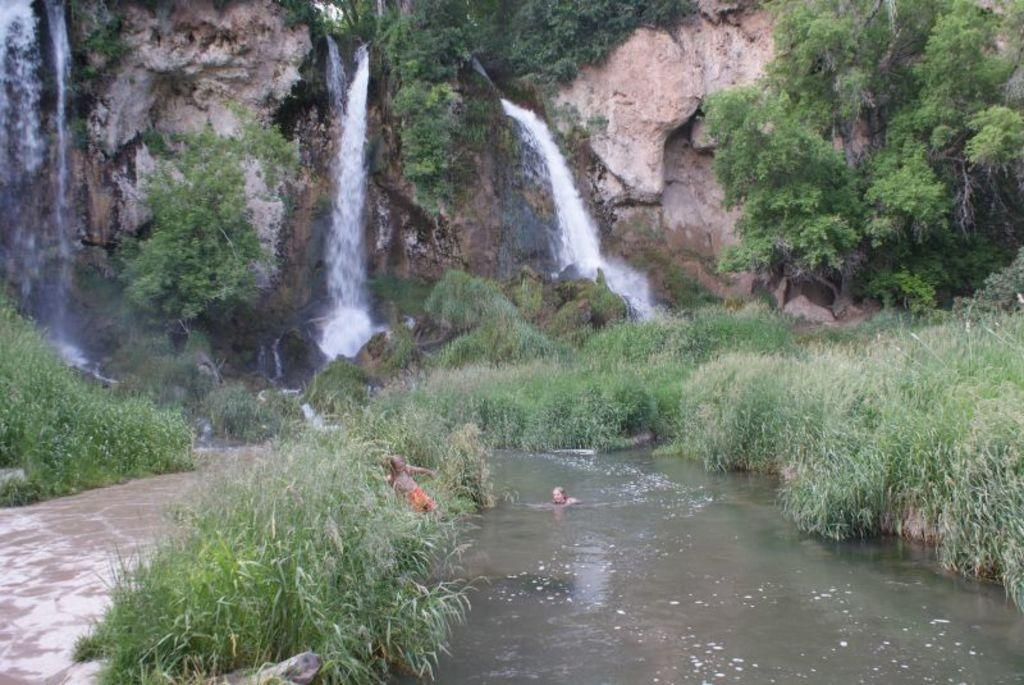What type of living organisms can be seen in the image? Plants are visible in the image. What natural element is present in the image? Water is visible in the image. What is the person in the water doing? The person is partially in the water. Where is the other person located in the image? The other person is at the bushes. What can be seen in the background of the image? There are plants, trees, and a waterfall in the background of the image. What geographical feature is visible in the background of the image? A cliff is visible in the background of the image. What type of cake is being served in the lunchroom in the image? There is no cake or lunchroom present in the image; it features plants, water, and people near a body of water. What type of camera is being used to take the picture in the image? There is no camera visible in the image, as the image itself is being observed. 